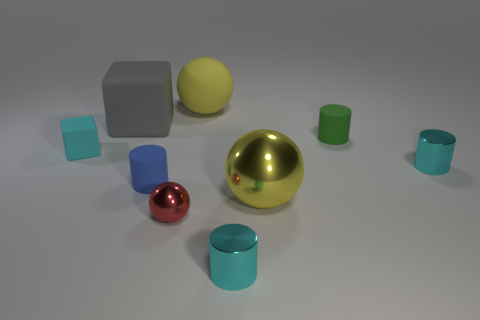What can you infer about the material of the red object? The small red object in the foreground has a high-gloss finish, suggesting that it's made of a reflective material like polished metal or plastic. Its vibrant red color adds a pop of contrast to the scene. 